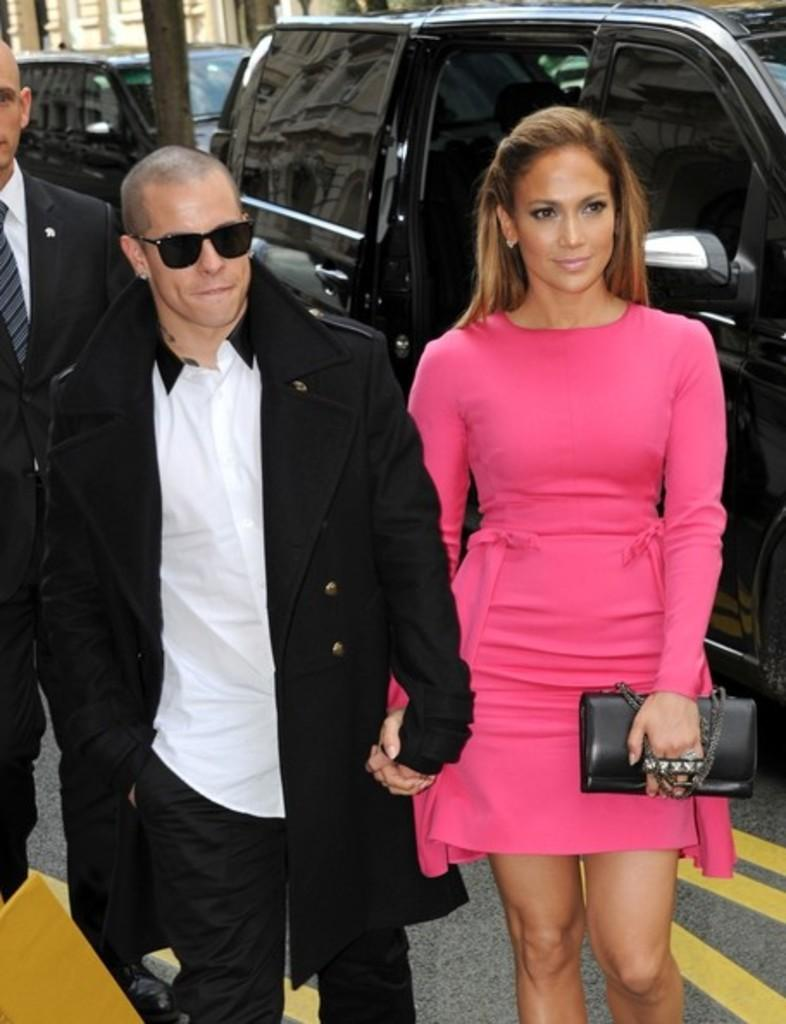Who can be seen in the image? There is a couple standing in the image. What can be seen in the distance behind the couple? There is a car and a building in the background of the image. How many letters are visible on the lamp in the image? There is no lamp present in the image, so it is not possible to determine how many letters might be visible on it. 